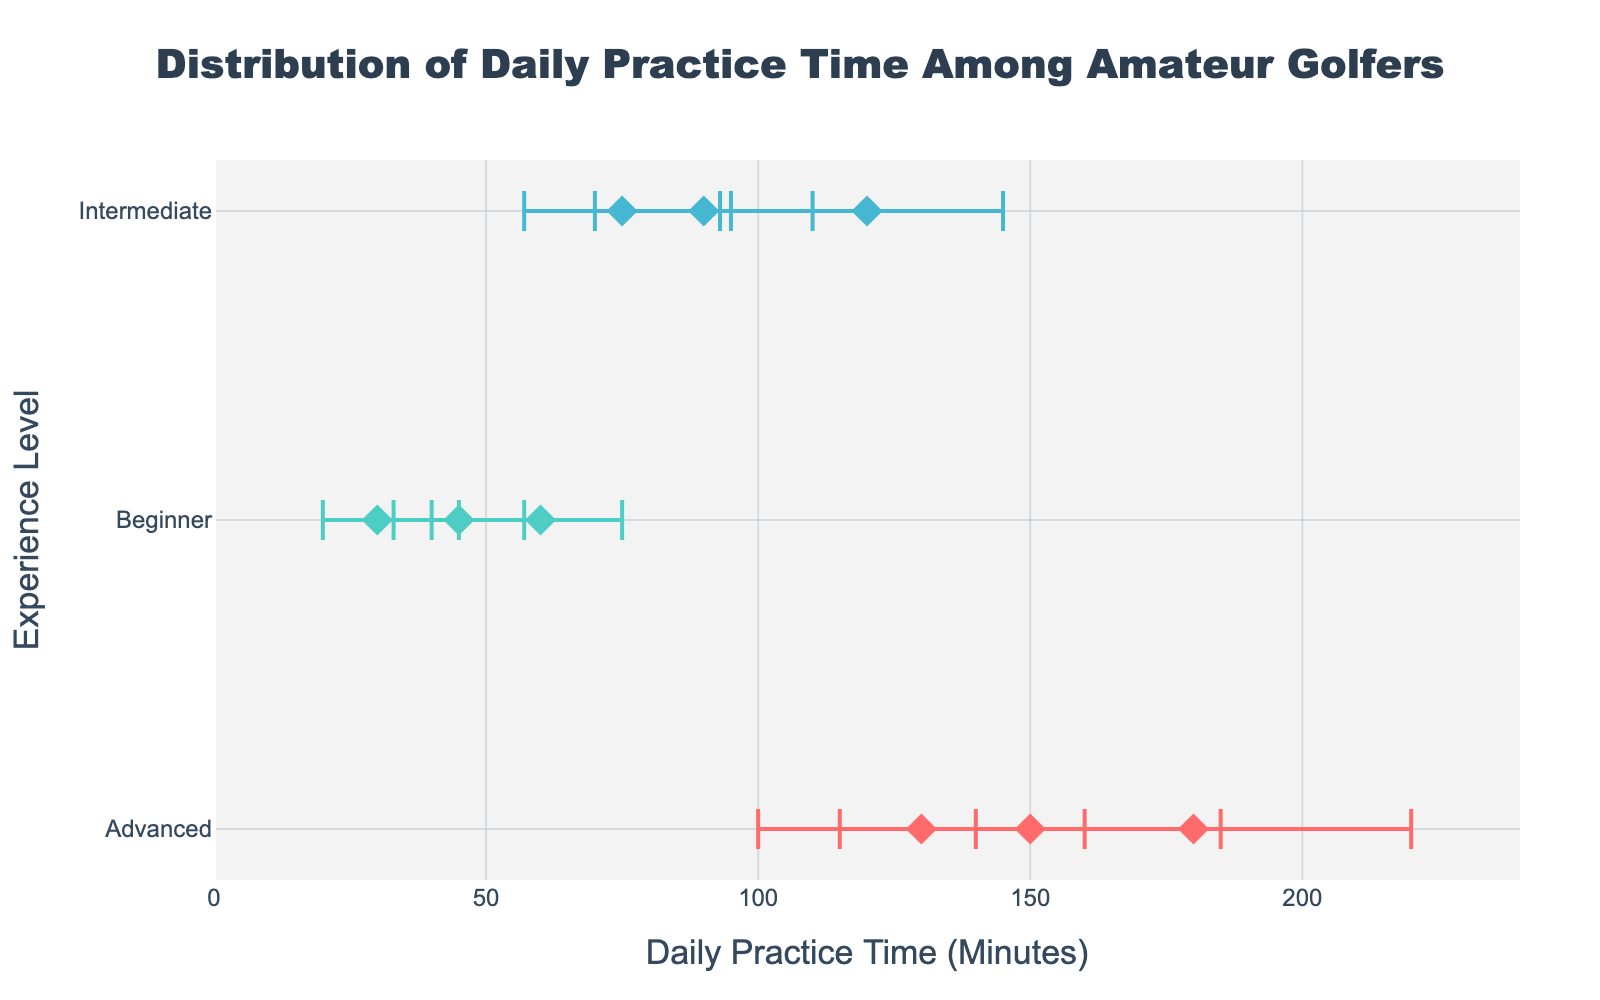What is the title of the figure? The title is usually clearly displayed at the top of the figure.
Answer: Distribution of Daily Practice Time Among Amateur Golfers Which experience level has the widest variability in daily practice time? The widest variability is indicated by the longest error bars. The Advanced level has the longest error bars, indicating the widest variability.
Answer: Advanced How many data points are there for each experience level? Count the markers for each experience level. Beginners have 3, Intermediates have 3, and Advanced have 3 data points.
Answer: 3 each What is the mean daily practice time for Intermediate players? Look at the x-axis value of the markers for the Intermediate level. The means are 120, 90, and 75.
Answer: 120, 90, 75 Which experience level has the highest average mean daily practice time? Compare the mean values of each experience level. Advanced has the highest values: 180, 150, and 130.
Answer: Advanced What is the difference between the highest and lowest mean daily practice times for Beginners? Identify the highest and lowest means for Beginners (60 and 30), then subtract the lowest from the highest.
Answer: 30 What is the average of means for the Advanced players? Sum the means for Advanced players (180 + 150 + 130) and divide by the number of data points (3).
Answer: 153.33 Which group shows the lowest mean daily practice time? Identify the lowest mean across all experience levels. Beginners have the lowest mean with 30 minutes.
Answer: Beginners Do Intermediate players have more variability than Beginners? Compare the length of the error bars for Intermediate and Beginner groups. Intermediates generally have longer error bars than Beginners, indicating more variability.
Answer: Yes 